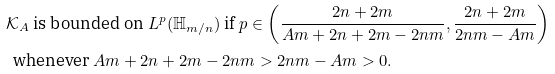<formula> <loc_0><loc_0><loc_500><loc_500>& \mathcal { K } _ { A } \text { is bounded on } L ^ { p } ( \mathbb { H } _ { m / n } ) \text { if } p \in \left ( \frac { 2 n + 2 m } { A m + 2 n + 2 m - 2 n m } , \frac { 2 n + 2 m } { 2 n m - A m } \right ) \\ & \, \text { whenever } A m + 2 n + 2 m - 2 n m > 2 n m - A m > 0 .</formula> 